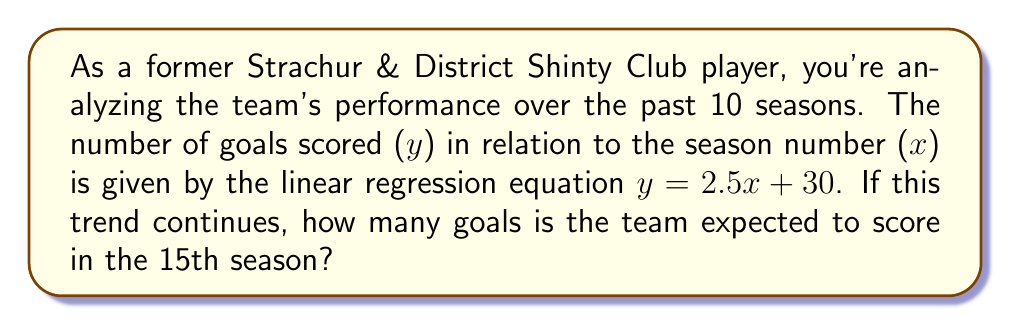What is the answer to this math problem? Let's approach this step-by-step:

1) We are given the linear regression equation:
   $y = 2.5x + 30$

   Where:
   $y$ = number of goals scored
   $x$ = season number

2) We need to find $y$ when $x = 15$ (15th season)

3) Let's substitute $x = 15$ into the equation:

   $y = 2.5(15) + 30$

4) Now, let's solve:

   $y = 37.5 + 30$
   $y = 67.5$

5) Since we're dealing with goals, which must be whole numbers, we round to the nearest integer:

   $y ≈ 68$

Therefore, if the trend continues, the team is expected to score 68 goals in the 15th season.
Answer: 68 goals 